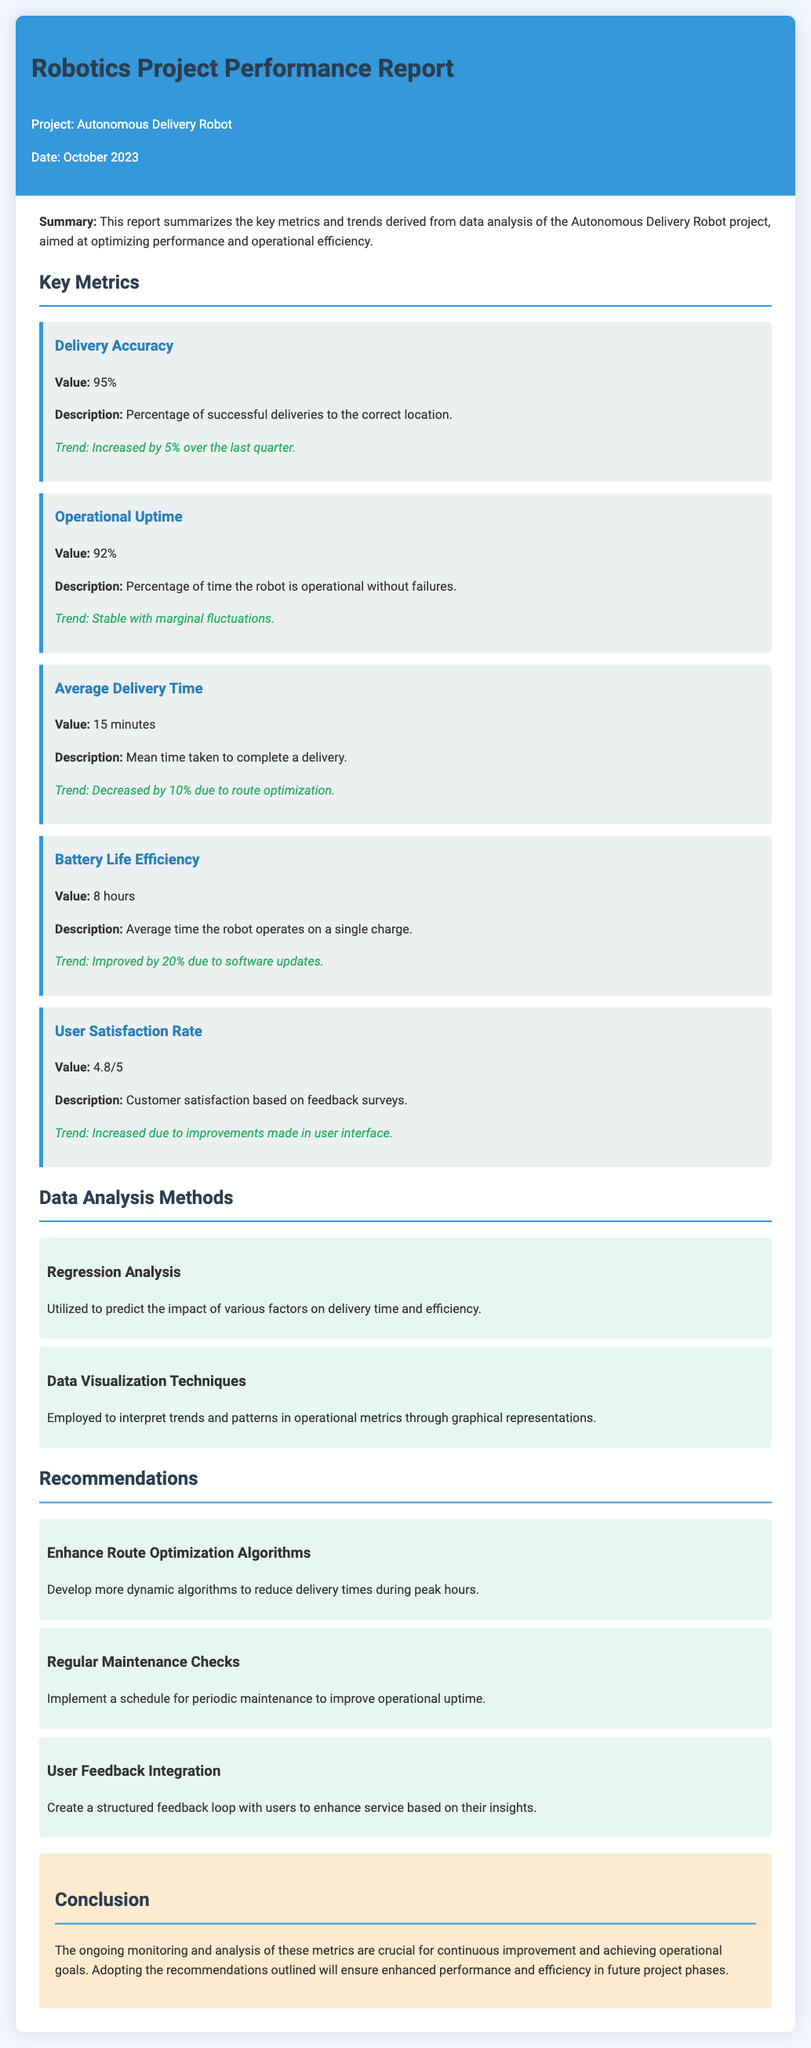What is the project name? The project name is indicated in the header of the report.
Answer: Autonomous Delivery Robot What is the delivery accuracy percentage? Delivery accuracy is mentioned in the key metrics section of the report.
Answer: 95% What was the trend change in average delivery time? The trend of average delivery time is summarized in the metrics section.
Answer: Decreased by 10% What is the user satisfaction rate? The user satisfaction rate is found in the key metrics section.
Answer: 4.8/5 What recommendation is given for route optimization? The recommendations section outlines suggestions for improving route algorithms.
Answer: Enhance Route Optimization Algorithms How much did battery life efficiency improve by? The improvement in battery life efficiency is detailed in the corresponding metric.
Answer: Improved by 20% What data analysis method predicts the impact on delivery time? The methods used for data analysis are discussed, including which one predicts impacts.
Answer: Regression Analysis What date is the report published? The publication date is noted in the header section of the report.
Answer: October 2023 What is the operational uptime percentage? Operational uptime is specified in the key metrics area of the report.
Answer: 92% 